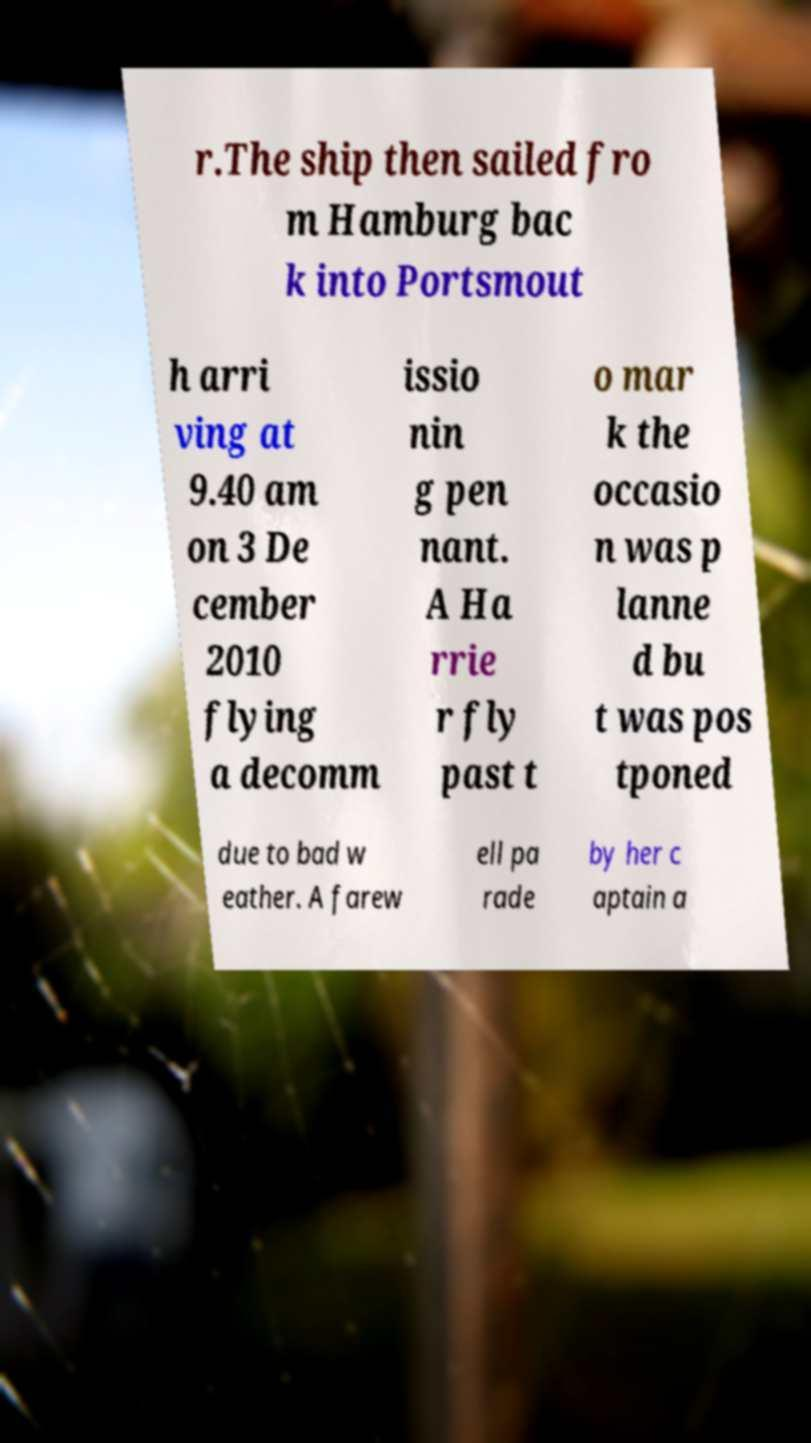Could you extract and type out the text from this image? r.The ship then sailed fro m Hamburg bac k into Portsmout h arri ving at 9.40 am on 3 De cember 2010 flying a decomm issio nin g pen nant. A Ha rrie r fly past t o mar k the occasio n was p lanne d bu t was pos tponed due to bad w eather. A farew ell pa rade by her c aptain a 